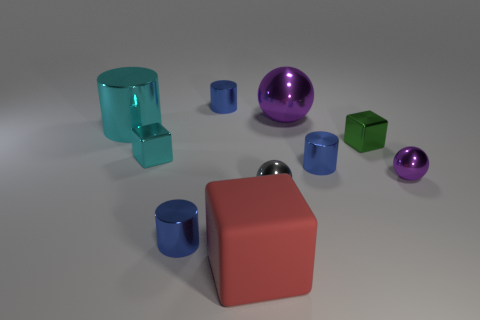Subtract all blue metallic cylinders. How many cylinders are left? 1 Subtract all green blocks. How many blocks are left? 2 Subtract all cylinders. How many objects are left? 6 Subtract all gray balls. Subtract all brown cylinders. How many balls are left? 2 Subtract all brown cylinders. How many purple balls are left? 2 Subtract all brown cylinders. Subtract all tiny purple balls. How many objects are left? 9 Add 9 big shiny cylinders. How many big shiny cylinders are left? 10 Add 1 green metal cubes. How many green metal cubes exist? 2 Subtract 0 yellow cylinders. How many objects are left? 10 Subtract 1 cylinders. How many cylinders are left? 3 